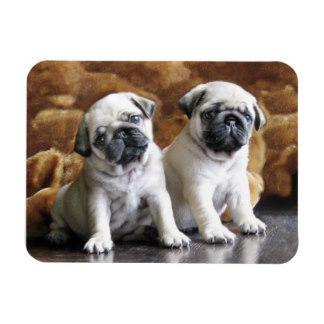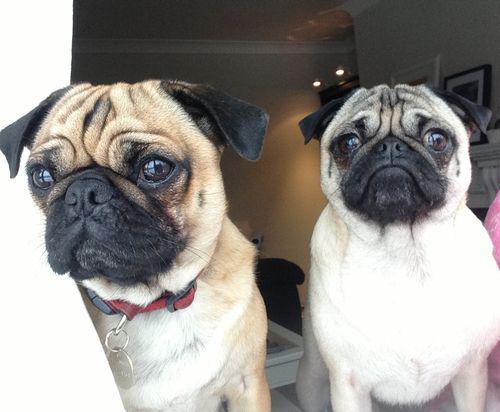The first image is the image on the left, the second image is the image on the right. Given the left and right images, does the statement "two pugs are wearing costumes" hold true? Answer yes or no. No. The first image is the image on the left, the second image is the image on the right. Given the left and right images, does the statement "Each image shows two buff-beige pugs with darker muzzles posed side-by-side facing forward." hold true? Answer yes or no. Yes. 